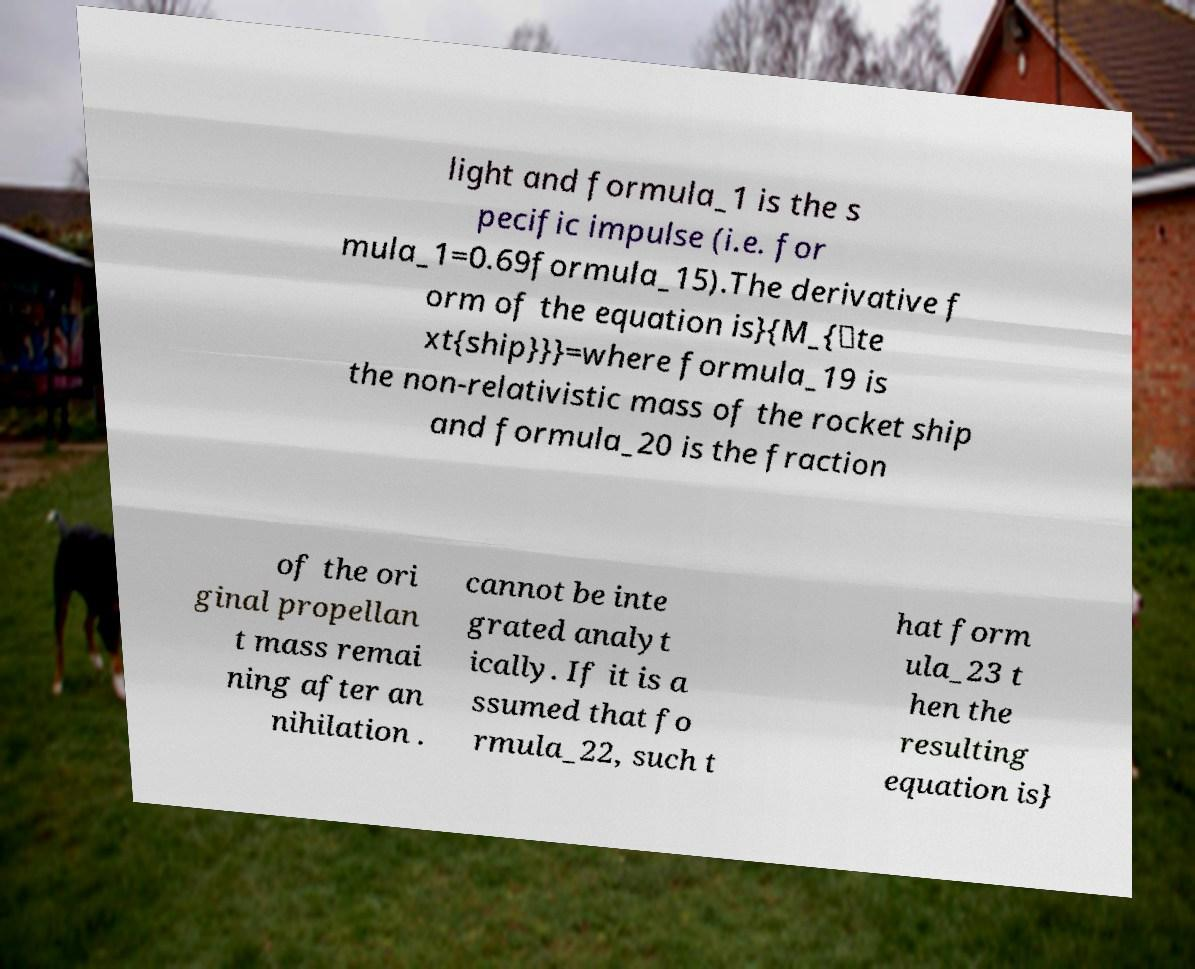For documentation purposes, I need the text within this image transcribed. Could you provide that? light and formula_1 is the s pecific impulse (i.e. for mula_1=0.69formula_15).The derivative f orm of the equation is}{M_{\te xt{ship}}}=where formula_19 is the non-relativistic mass of the rocket ship and formula_20 is the fraction of the ori ginal propellan t mass remai ning after an nihilation . cannot be inte grated analyt ically. If it is a ssumed that fo rmula_22, such t hat form ula_23 t hen the resulting equation is} 